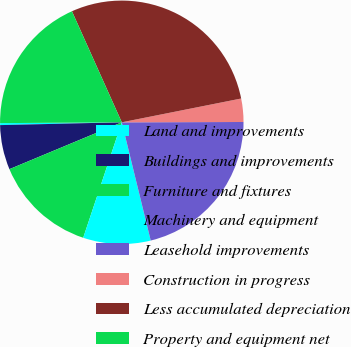<chart> <loc_0><loc_0><loc_500><loc_500><pie_chart><fcel>Land and improvements<fcel>Buildings and improvements<fcel>Furniture and fixtures<fcel>Machinery and equipment<fcel>Leasehold improvements<fcel>Construction in progress<fcel>Less accumulated depreciation<fcel>Property and equipment net<nl><fcel>0.26%<fcel>5.92%<fcel>13.58%<fcel>8.95%<fcel>21.22%<fcel>3.09%<fcel>28.58%<fcel>18.39%<nl></chart> 